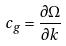<formula> <loc_0><loc_0><loc_500><loc_500>c _ { g } = \frac { \partial \Omega } { \partial k }</formula> 